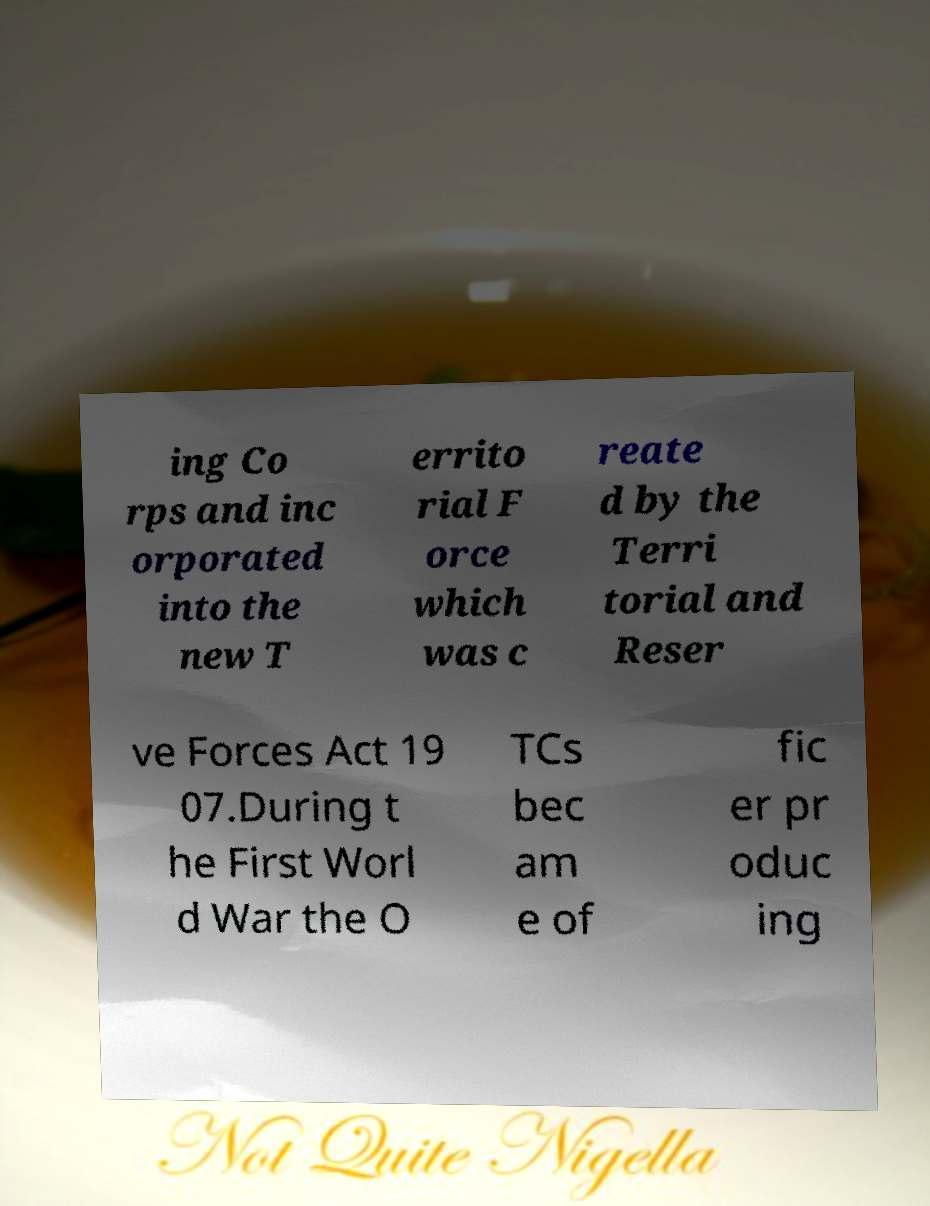Please identify and transcribe the text found in this image. ing Co rps and inc orporated into the new T errito rial F orce which was c reate d by the Terri torial and Reser ve Forces Act 19 07.During t he First Worl d War the O TCs bec am e of fic er pr oduc ing 